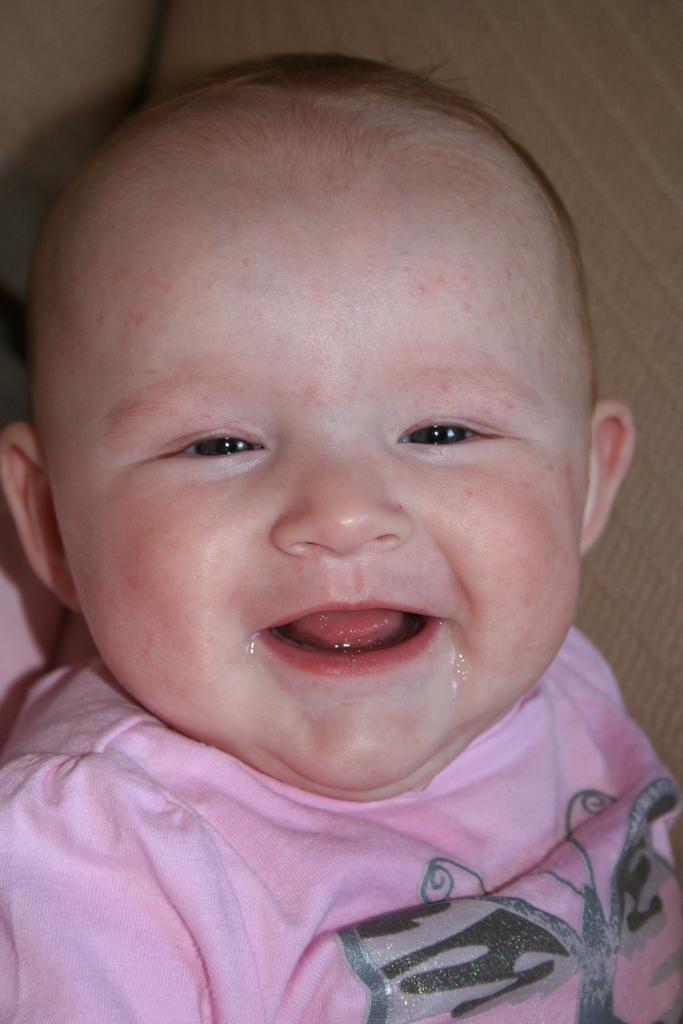How would you summarize this image in a sentence or two? In the center of the image a baby is there. 